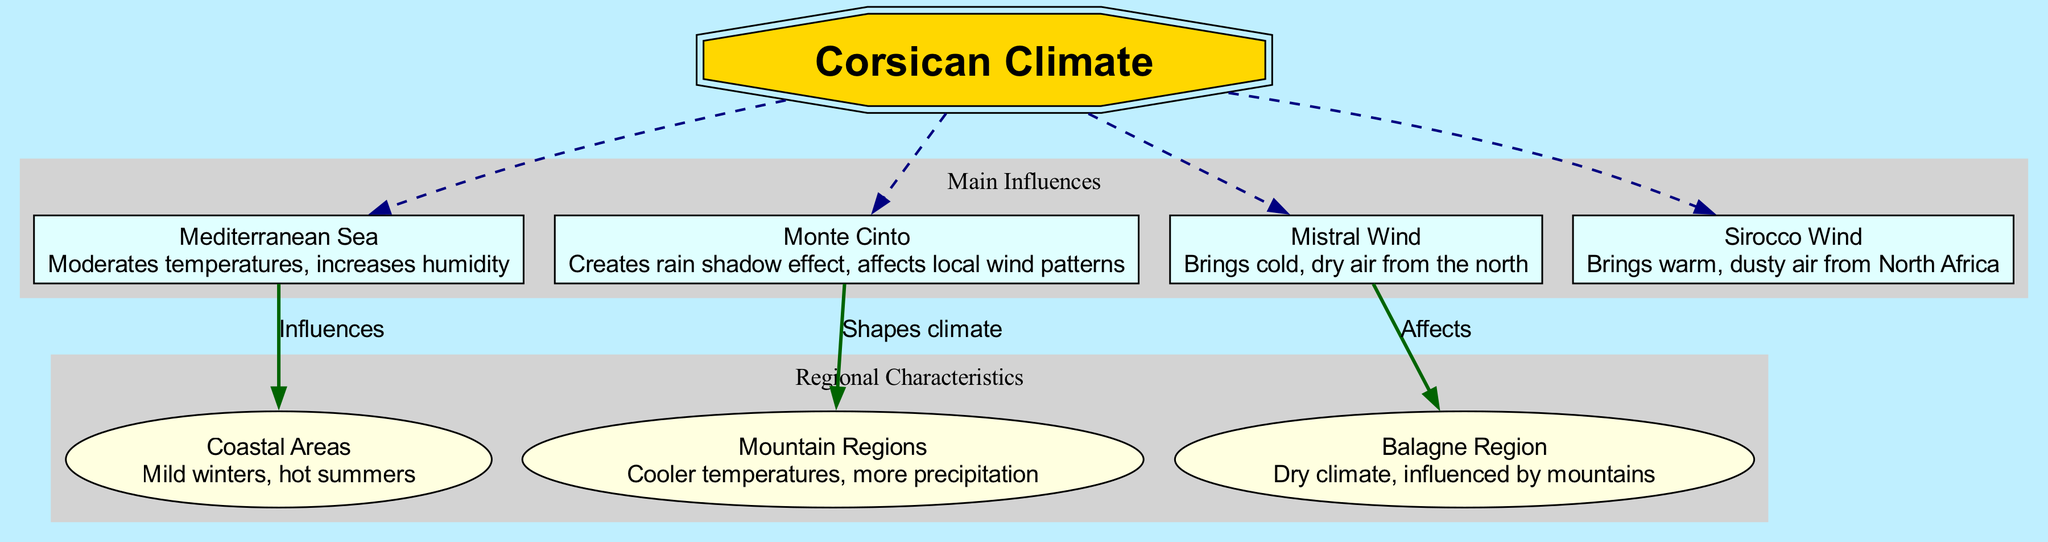How many main elements are there in the diagram? The diagram has a list of main elements, which can be counted as we go through the section labeled 'Main Influences.' In this case, there are four main elements listed.
Answer: 4 What effect does the Mediterranean Sea have on temperatures? The Mediterranean Sea is noted in the diagram as moderating temperatures, which indicates that it contributes to more stable and comfortable temperature ranges in the coastal areas.
Answer: Moderates temperatures What is the main influence of Monte Cinto? Referring to the influence stated next to Monte Cinto in the diagram, it shapes the climate by creating a rain shadow effect that impacts local weather patterns.
Answer: Creates rain shadow effect Which region is affected by the Mistral Wind? The Mistral Wind's effects on the diagram are directed specifically towards the Balagne Region, where it impacts local weather conditions.
Answer: Balagne Region What is characterized by mild winters and hot summers? When reviewing the sub-elements outlined in the diagram, the Coastal Areas are described as having these specific climatic characteristics, which fit the question's description.
Answer: Coastal Areas Explain the relationship between Monte Cinto and Mountain Regions. The Monte Cinto, according to the connections in the diagram, shapes the climate specifically for the Mountain Regions, indicating that the mountain's presence directly influences the regional weather and climate characteristics.
Answer: Shapes climate Which wind brings warm, dusty air from North Africa? The diagram specifies the Sirocco Wind, which is indicated as responsible for bringing warmer, dust-laden air from the African continent to the Corsican climate.
Answer: Sirocco Wind How does the Mediterranean Sea influence the Coastal Areas? In the diagram, a direct connection shows that the Mediterranean Sea influences the Coastal Areas by moderating temperatures, which results in a more pleasant climate for those regions.
Answer: Influences Which region experiences cooler temperatures and more precipitation? By examining the characteristics noted for different sub-elements, the Mountain Regions are explicitly mentioned as experiencing such climatic conditions.
Answer: Mountain Regions 